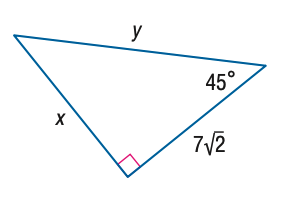Question: Find y.
Choices:
A. 7
B. 7 \sqrt { 2 }
C. 14
D. 14 \sqrt { 2 }
Answer with the letter. Answer: C 